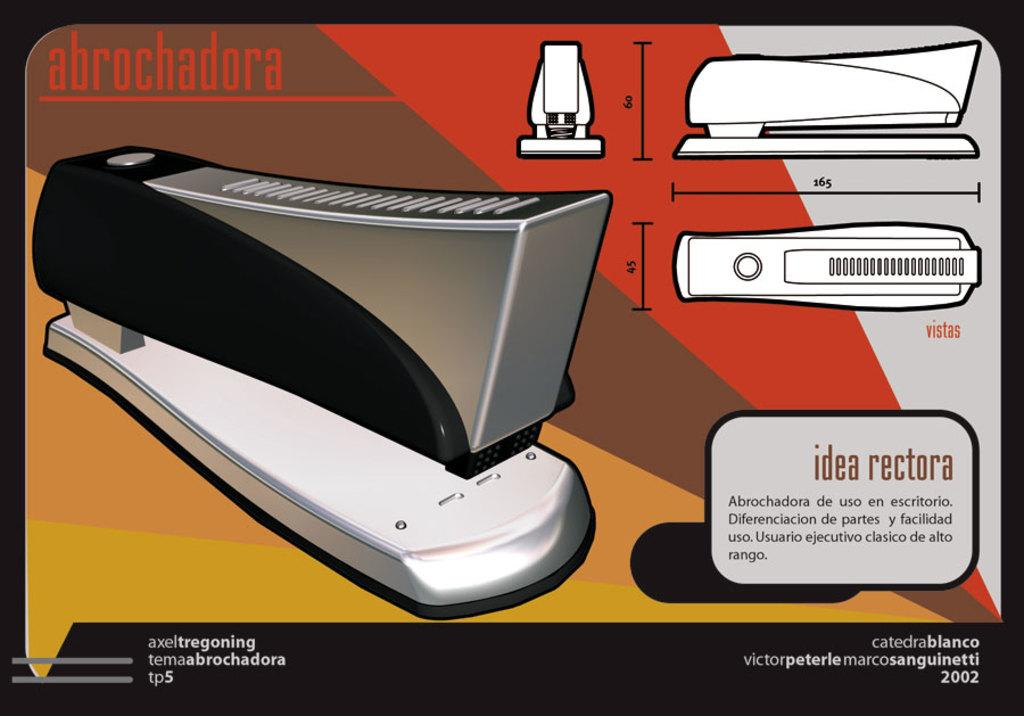<image>
Relay a brief, clear account of the picture shown. An informational drawing for the abrochadora stapler from 2002. 